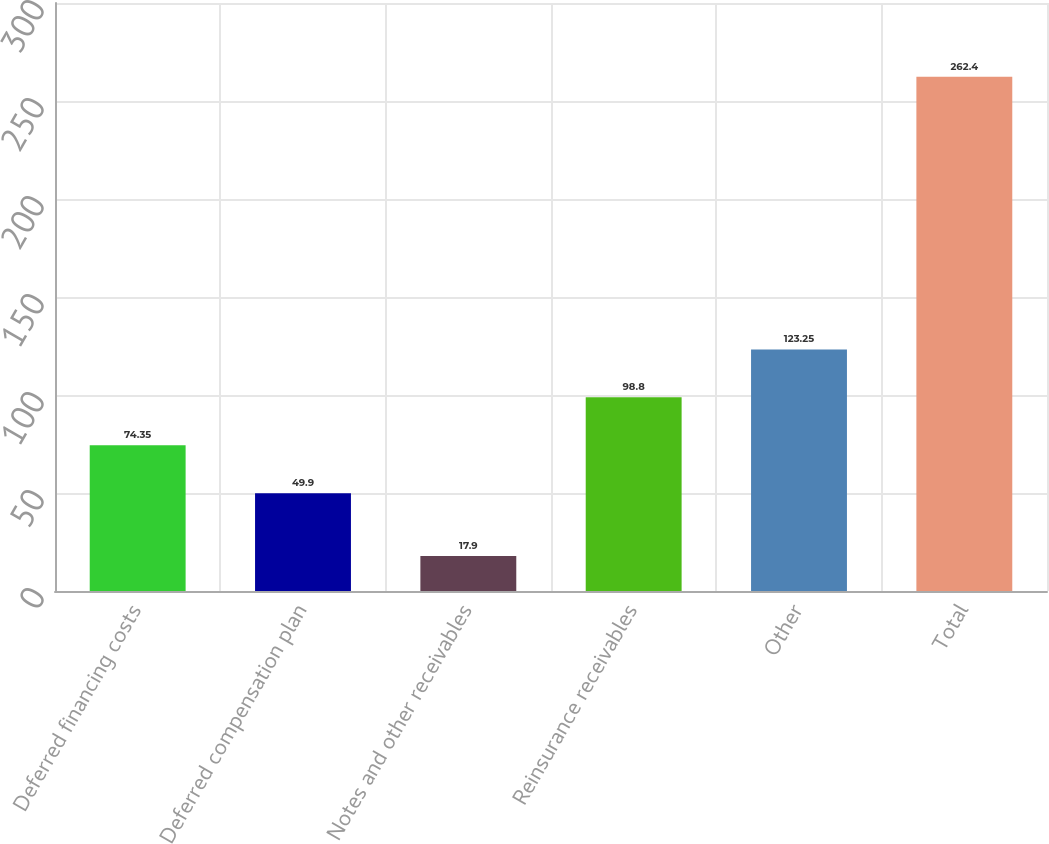Convert chart to OTSL. <chart><loc_0><loc_0><loc_500><loc_500><bar_chart><fcel>Deferred financing costs<fcel>Deferred compensation plan<fcel>Notes and other receivables<fcel>Reinsurance receivables<fcel>Other<fcel>Total<nl><fcel>74.35<fcel>49.9<fcel>17.9<fcel>98.8<fcel>123.25<fcel>262.4<nl></chart> 